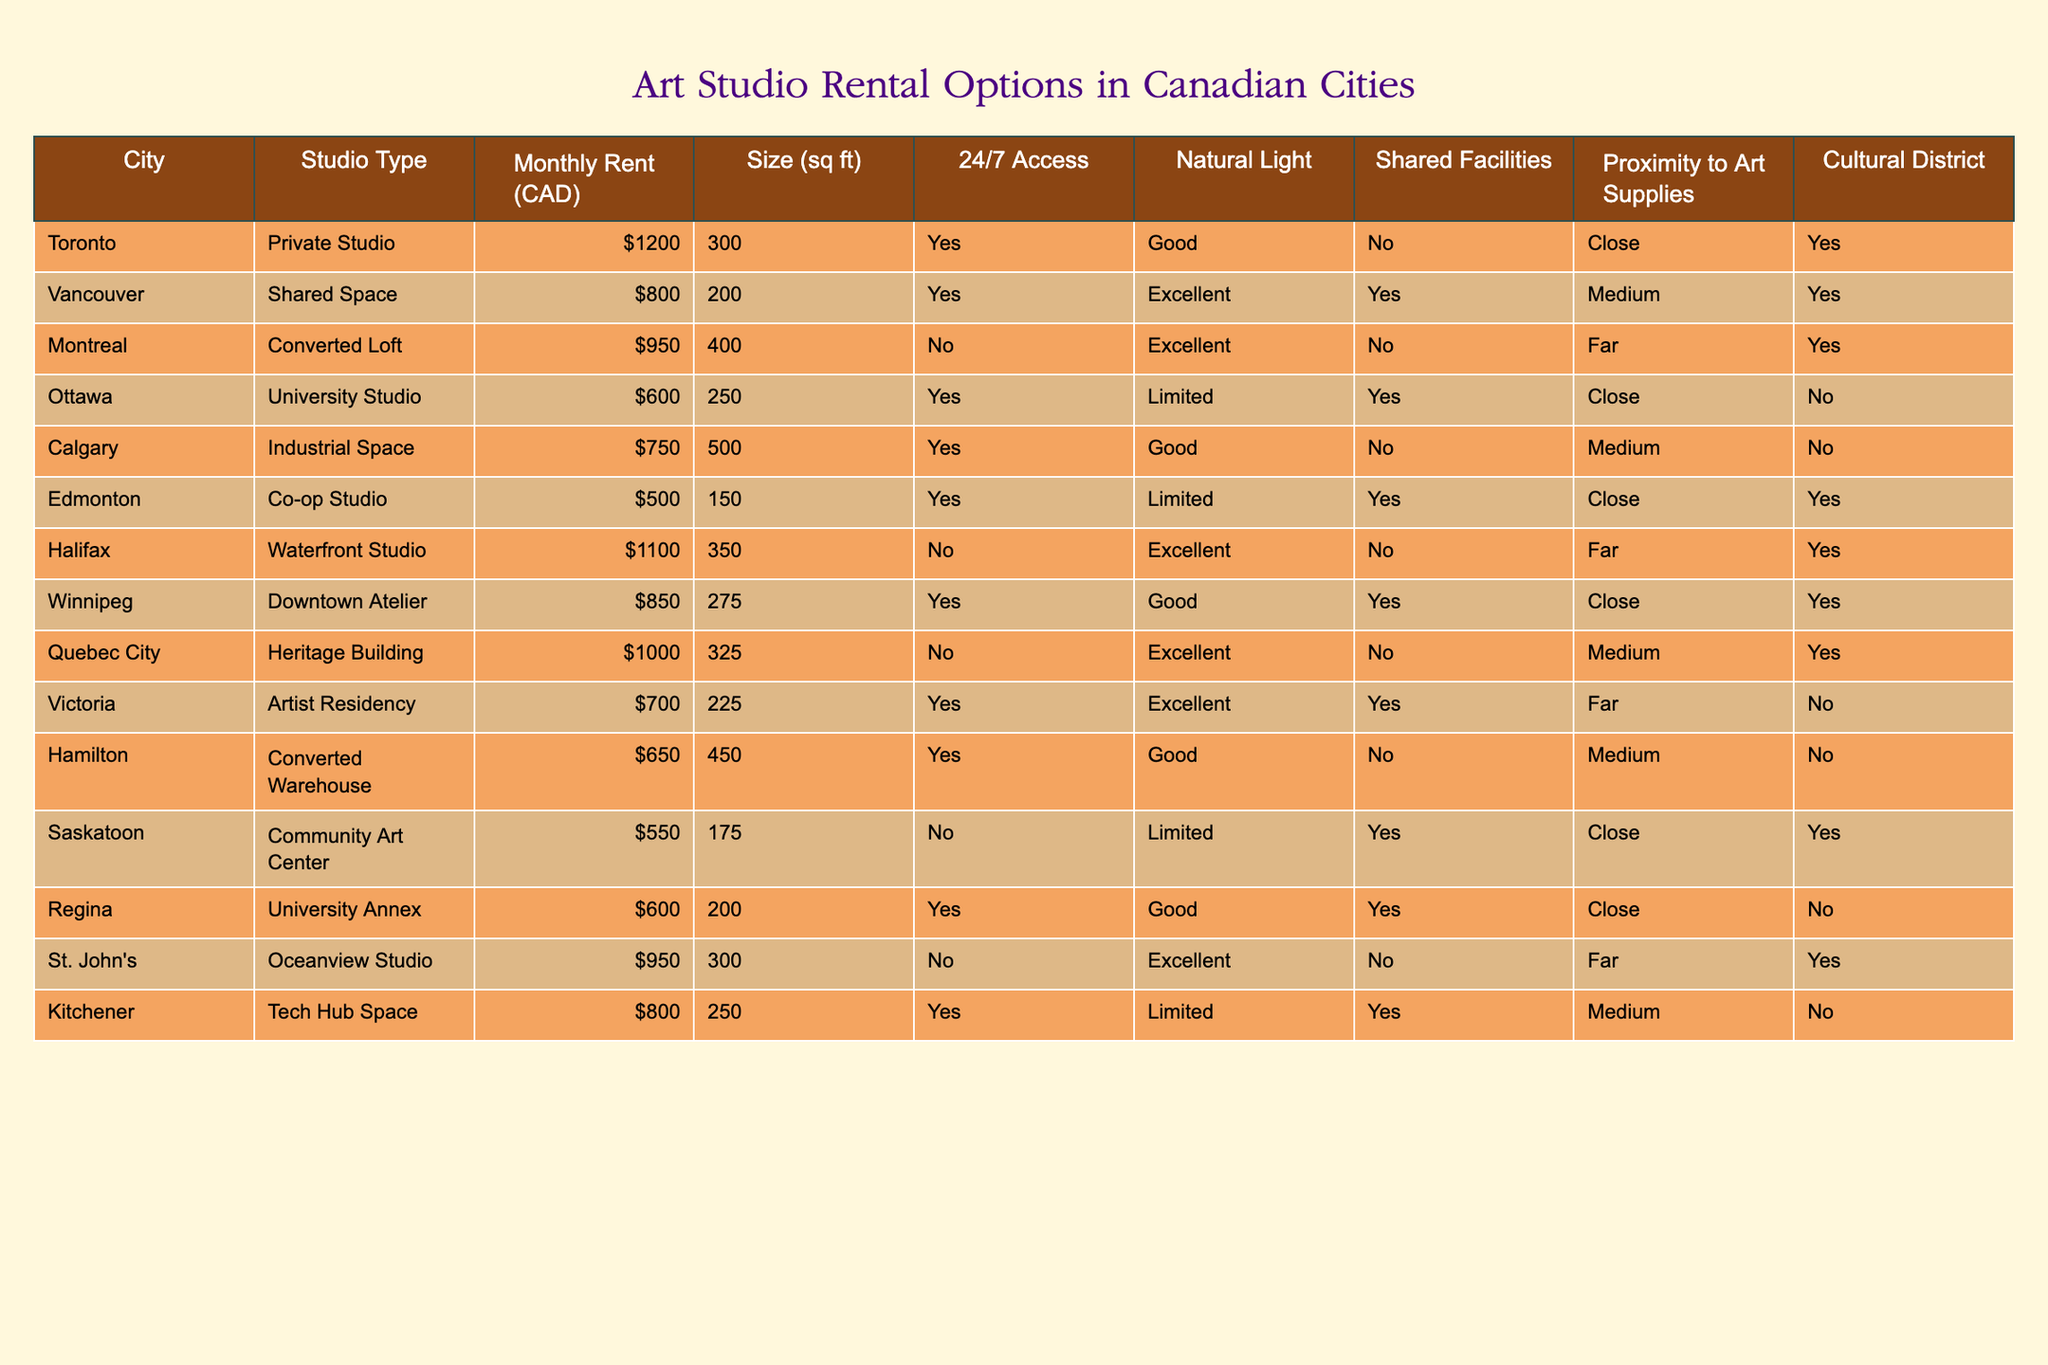What is the monthly rent for the Private Studio in Toronto? The table lists the monthly rent for the Private Studio in Toronto as 1200 CAD.
Answer: 1200 CAD Which studio type in Vancouver offers the most natural light? The table indicates that the Shared Space in Vancouver has Excellent natural light, which is the highest rating among studio types listed in the city.
Answer: Shared Space How many studios in the Cultural District have 24/7 access? The studios in the Cultural District are Toronto (Private Studio), Vancouver (Shared Space), Montreal (Converted Loft), Halifax (Waterfront Studio), Quebec City (Heritage Building). Among these, only the Toronto and Vancouver studios have 24/7 access (Yes). Therefore, there are 2 studios with 24/7 access in the Cultural District.
Answer: 2 What is the total monthly rent for all studios that provide Limited natural light? The studios that provide Limited natural light are Ottawa (University Studio, 600 CAD) and Edmonton (Co-op Studio, 500 CAD). Adding these rents together gives 600 + 500 = 1100 CAD for the total.
Answer: 1100 CAD Which city offers the cheapest studio that is close to art supplies and in the Cultural District? The Edmonton Co-op Studio at 500 CAD is the cheapest option that is close to art supplies and is located in the Cultural District. The other options, such as the Ottawa studio, are more expensive.
Answer: Edmonton Co-op Studio Is there a studio in Calgary that has Natural Light rated as Excellent? Referring to the table, the Industrial Space in Calgary has Good natural light, while no studio in Calgary shows Excellent natural light. Thus, the answer to the question is No.
Answer: No What is the average size of studios in cities with shared facilities? The studios with shared facilities are Vancouver (Shared Space, 200 sq ft), Ottawa (University Studio, 250 sq ft), Edmonton (Co-op Studio, 150 sq ft), and Winnipeg (Downtown Atelier, 275 sq ft). The average size is (200 + 250 + 150 + 275) / 4 = 218.75 sq ft.
Answer: 218.75 sq ft Which studio has the highest monthly rent and is located closest to an art supply store? The Waterfront Studio in Halifax has the highest rent of 1100 CAD. However, proximity to art supplies is categorized as Far. The next highest rent is the Private Studio in Toronto at 1200 CAD, with Close proximity to art supplies. Thus, the highest rent with Close proximity is the Private Studio in Toronto.
Answer: Private Studio in Toronto How many studios outside the Cultural District have 24/7 access? The studios outside the Cultural District with 24/7 access are Ottawa (University Studio) and Calgary (Industrial Space), which totals to 2 studios outside the Cultural District with 24/7 access.
Answer: 2 